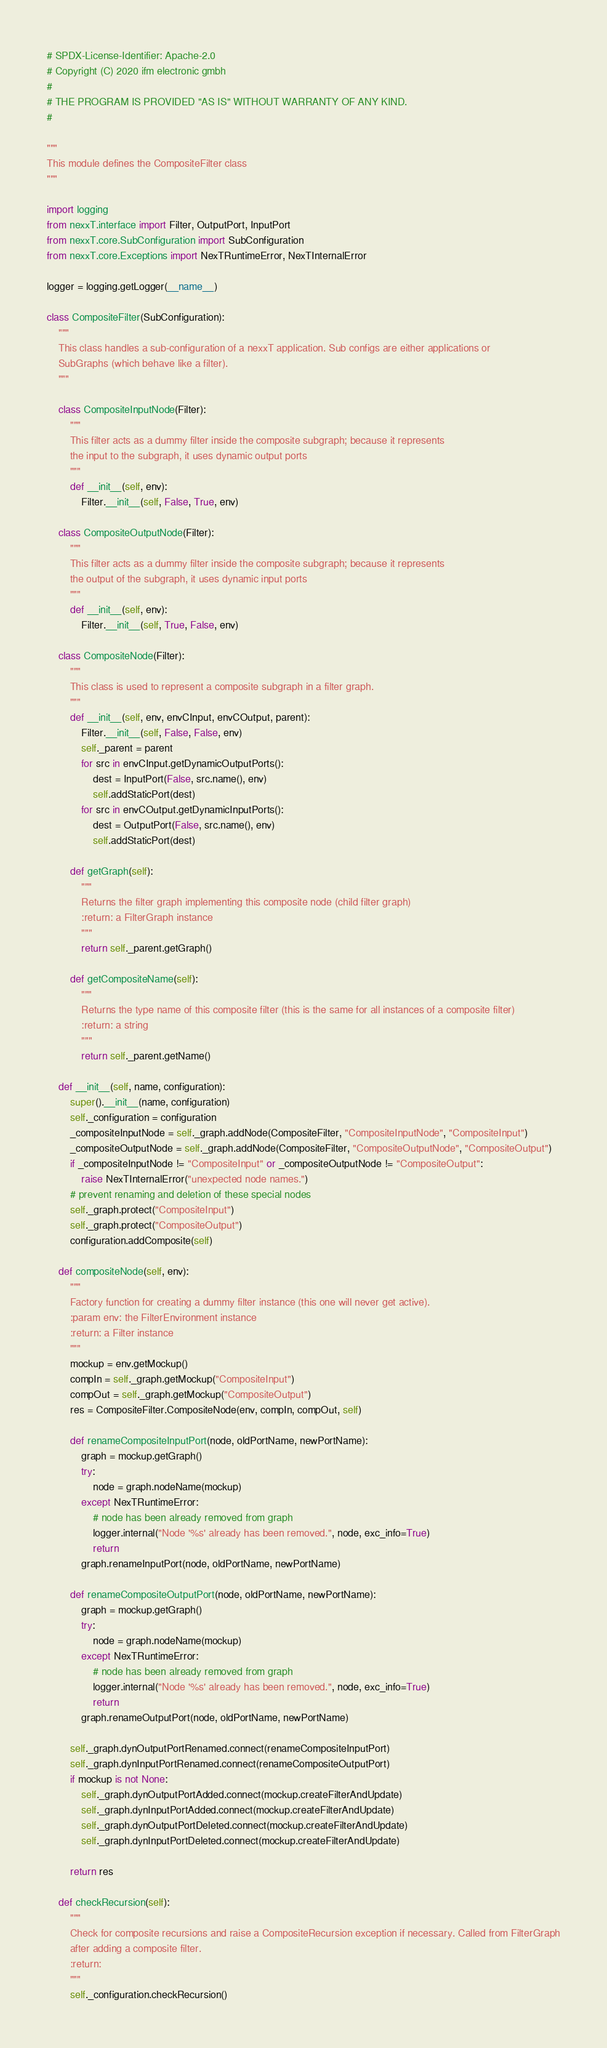Convert code to text. <code><loc_0><loc_0><loc_500><loc_500><_Python_># SPDX-License-Identifier: Apache-2.0
# Copyright (C) 2020 ifm electronic gmbh
#
# THE PROGRAM IS PROVIDED "AS IS" WITHOUT WARRANTY OF ANY KIND.
#

"""
This module defines the CompositeFilter class
"""

import logging
from nexxT.interface import Filter, OutputPort, InputPort
from nexxT.core.SubConfiguration import SubConfiguration
from nexxT.core.Exceptions import NexTRuntimeError, NexTInternalError

logger = logging.getLogger(__name__)

class CompositeFilter(SubConfiguration):
    """
    This class handles a sub-configuration of a nexxT application. Sub configs are either applications or
    SubGraphs (which behave like a filter).
    """

    class CompositeInputNode(Filter):
        """
        This filter acts as a dummy filter inside the composite subgraph; because it represents
        the input to the subgraph, it uses dynamic output ports
        """
        def __init__(self, env):
            Filter.__init__(self, False, True, env)

    class CompositeOutputNode(Filter):
        """
        This filter acts as a dummy filter inside the composite subgraph; because it represents
        the output of the subgraph, it uses dynamic input ports
        """
        def __init__(self, env):
            Filter.__init__(self, True, False, env)

    class CompositeNode(Filter):
        """
        This class is used to represent a composite subgraph in a filter graph.
        """
        def __init__(self, env, envCInput, envCOutput, parent):
            Filter.__init__(self, False, False, env)
            self._parent = parent
            for src in envCInput.getDynamicOutputPorts():
                dest = InputPort(False, src.name(), env)
                self.addStaticPort(dest)
            for src in envCOutput.getDynamicInputPorts():
                dest = OutputPort(False, src.name(), env)
                self.addStaticPort(dest)

        def getGraph(self):
            """
            Returns the filter graph implementing this composite node (child filter graph)
            :return: a FilterGraph instance
            """
            return self._parent.getGraph()

        def getCompositeName(self):
            """
            Returns the type name of this composite filter (this is the same for all instances of a composite filter)
            :return: a string
            """
            return self._parent.getName()

    def __init__(self, name, configuration):
        super().__init__(name, configuration)
        self._configuration = configuration
        _compositeInputNode = self._graph.addNode(CompositeFilter, "CompositeInputNode", "CompositeInput")
        _compositeOutputNode = self._graph.addNode(CompositeFilter, "CompositeOutputNode", "CompositeOutput")
        if _compositeInputNode != "CompositeInput" or _compositeOutputNode != "CompositeOutput":
            raise NexTInternalError("unexpected node names.")
        # prevent renaming and deletion of these special nodes
        self._graph.protect("CompositeInput")
        self._graph.protect("CompositeOutput")
        configuration.addComposite(self)

    def compositeNode(self, env):
        """
        Factory function for creating a dummy filter instance (this one will never get active).
        :param env: the FilterEnvironment instance
        :return: a Filter instance
        """
        mockup = env.getMockup()
        compIn = self._graph.getMockup("CompositeInput")
        compOut = self._graph.getMockup("CompositeOutput")
        res = CompositeFilter.CompositeNode(env, compIn, compOut, self)

        def renameCompositeInputPort(node, oldPortName, newPortName):
            graph = mockup.getGraph()
            try:
                node = graph.nodeName(mockup)
            except NexTRuntimeError:
                # node has been already removed from graph
                logger.internal("Node '%s' already has been removed.", node, exc_info=True)
                return
            graph.renameInputPort(node, oldPortName, newPortName)

        def renameCompositeOutputPort(node, oldPortName, newPortName):
            graph = mockup.getGraph()
            try:
                node = graph.nodeName(mockup)
            except NexTRuntimeError:
                # node has been already removed from graph
                logger.internal("Node '%s' already has been removed.", node, exc_info=True)
                return
            graph.renameOutputPort(node, oldPortName, newPortName)

        self._graph.dynOutputPortRenamed.connect(renameCompositeInputPort)
        self._graph.dynInputPortRenamed.connect(renameCompositeOutputPort)
        if mockup is not None:
            self._graph.dynOutputPortAdded.connect(mockup.createFilterAndUpdate)
            self._graph.dynInputPortAdded.connect(mockup.createFilterAndUpdate)
            self._graph.dynOutputPortDeleted.connect(mockup.createFilterAndUpdate)
            self._graph.dynInputPortDeleted.connect(mockup.createFilterAndUpdate)

        return res

    def checkRecursion(self):
        """
        Check for composite recursions and raise a CompositeRecursion exception if necessary. Called from FilterGraph
        after adding a composite filter.
        :return:
        """
        self._configuration.checkRecursion()
</code> 